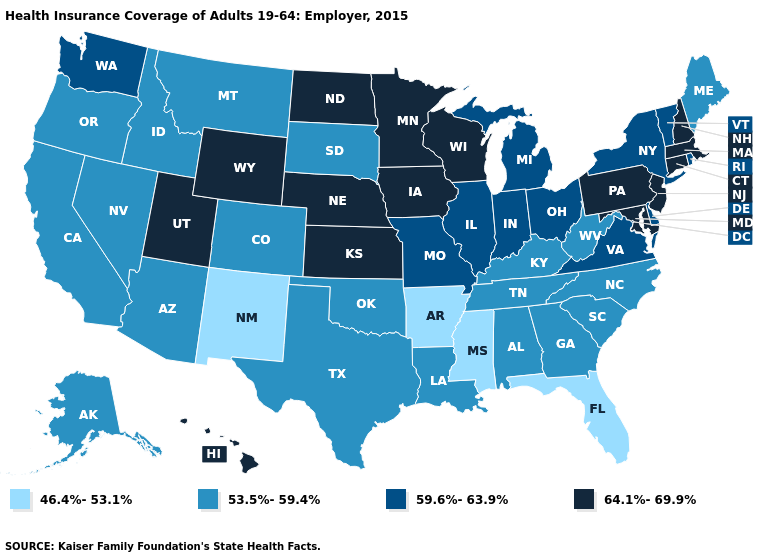Does Iowa have the highest value in the USA?
Be succinct. Yes. Name the states that have a value in the range 53.5%-59.4%?
Keep it brief. Alabama, Alaska, Arizona, California, Colorado, Georgia, Idaho, Kentucky, Louisiana, Maine, Montana, Nevada, North Carolina, Oklahoma, Oregon, South Carolina, South Dakota, Tennessee, Texas, West Virginia. What is the lowest value in states that border Wisconsin?
Give a very brief answer. 59.6%-63.9%. What is the value of Oregon?
Give a very brief answer. 53.5%-59.4%. Does Alabama have the same value as Montana?
Answer briefly. Yes. Name the states that have a value in the range 59.6%-63.9%?
Concise answer only. Delaware, Illinois, Indiana, Michigan, Missouri, New York, Ohio, Rhode Island, Vermont, Virginia, Washington. Which states hav the highest value in the South?
Quick response, please. Maryland. What is the value of Kansas?
Quick response, please. 64.1%-69.9%. What is the lowest value in the USA?
Write a very short answer. 46.4%-53.1%. Which states have the lowest value in the USA?
Give a very brief answer. Arkansas, Florida, Mississippi, New Mexico. Does Rhode Island have the highest value in the Northeast?
Short answer required. No. Which states have the highest value in the USA?
Be succinct. Connecticut, Hawaii, Iowa, Kansas, Maryland, Massachusetts, Minnesota, Nebraska, New Hampshire, New Jersey, North Dakota, Pennsylvania, Utah, Wisconsin, Wyoming. Name the states that have a value in the range 59.6%-63.9%?
Write a very short answer. Delaware, Illinois, Indiana, Michigan, Missouri, New York, Ohio, Rhode Island, Vermont, Virginia, Washington. What is the value of New York?
Short answer required. 59.6%-63.9%. What is the lowest value in the South?
Be succinct. 46.4%-53.1%. 